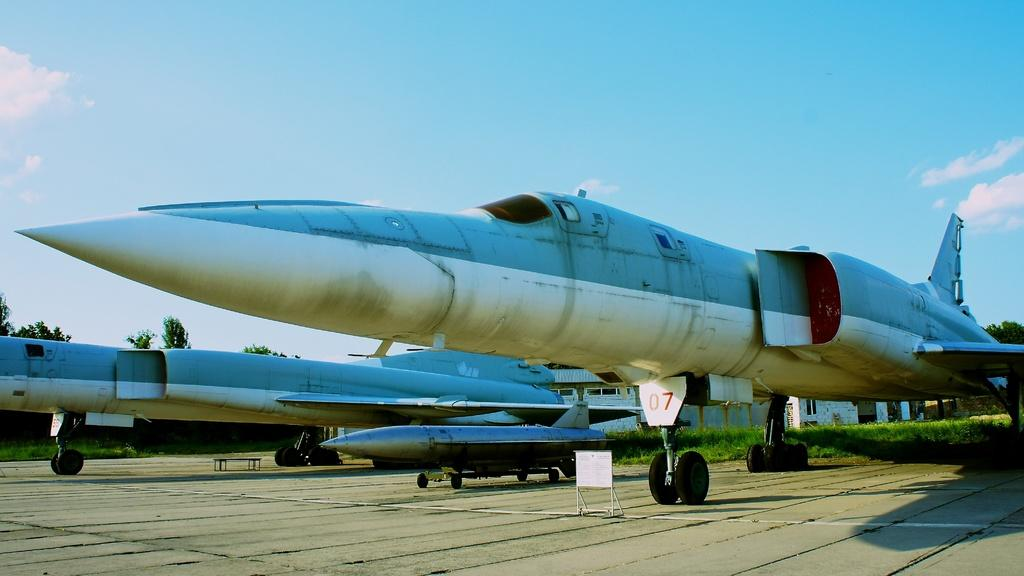<image>
Present a compact description of the photo's key features. A plane that is on the ground has the number 7 under it. 